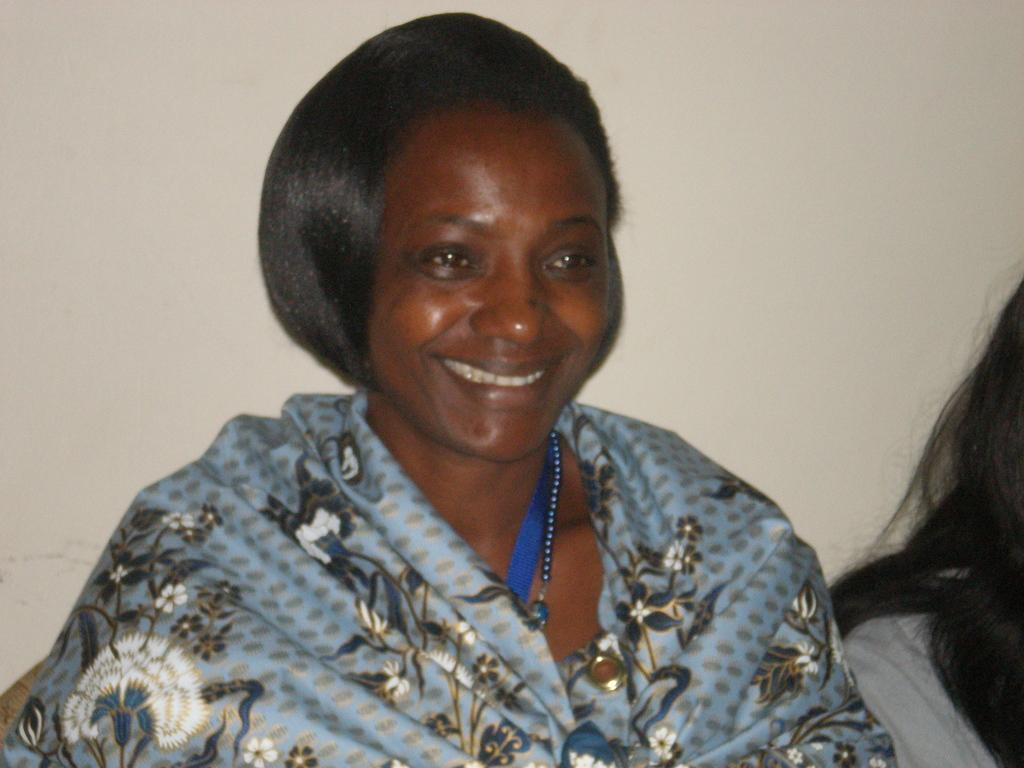What is the main subject of the image? The main subject of the image is a woman. Can you describe the woman's appearance? The woman is wearing a blue dress and smiling. Are there any other people in the image? Yes, there is another woman on the right side of the image. What can be seen in the background of the image? There is a wall in the background of the image. What type of carriage is being used for the distribution of goods in the image? There is no carriage or distribution of goods present in the image. How many seats are available for the audience in the image? There is no audience or seats present in the image. 